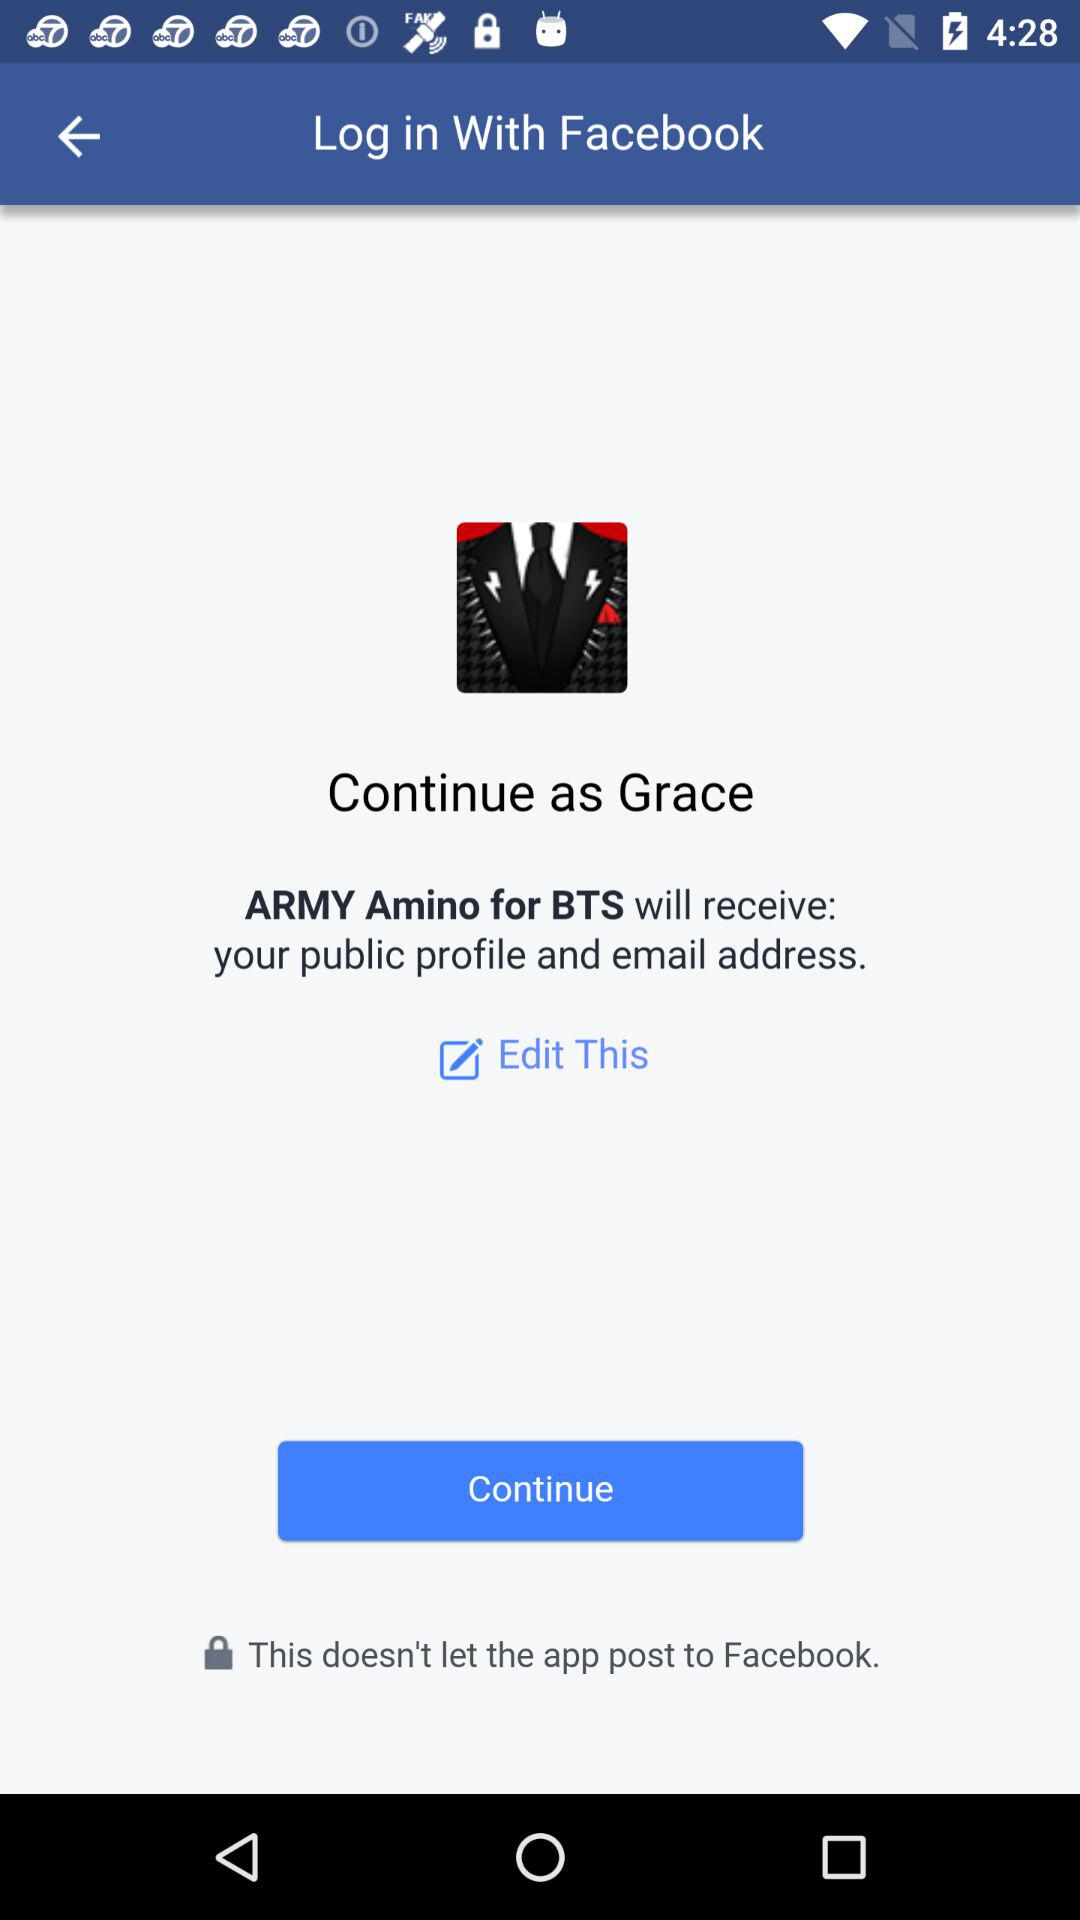What application is asking for permission? The application "ARMY Amino for BTS" is asking for permission. 